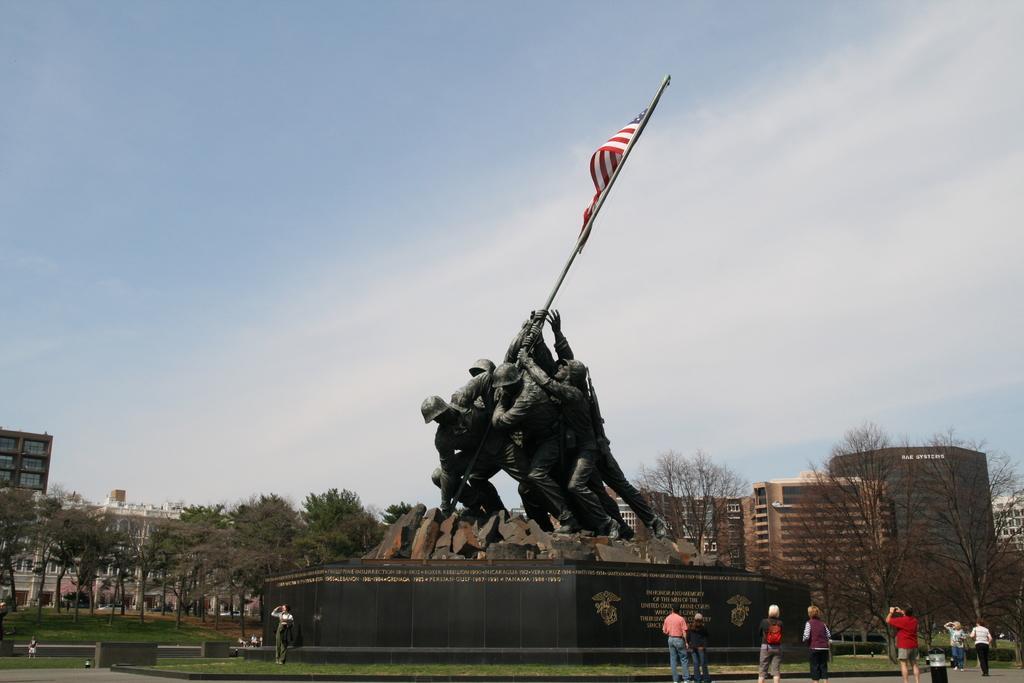How would you summarize this image in a sentence or two? In the middle of the image we can see few statues and a flag, in the background we can find few buildings and trees, also we can see group of people. 